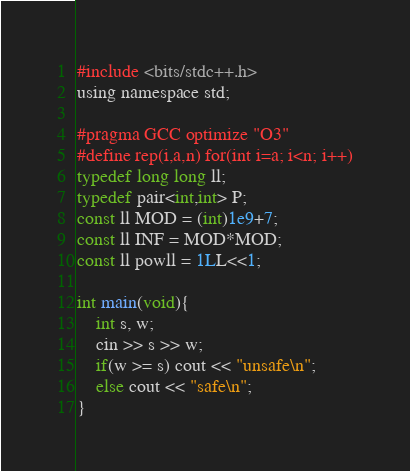<code> <loc_0><loc_0><loc_500><loc_500><_C_>#include <bits/stdc++.h>
using namespace std;

#pragma GCC optimize "O3"
#define rep(i,a,n) for(int i=a; i<n; i++)
typedef long long ll;
typedef pair<int,int> P;
const ll MOD = (int)1e9+7;
const ll INF = MOD*MOD;
const ll powll = 1LL<<1;

int main(void){
    int s, w;
    cin >> s >> w;
    if(w >= s) cout << "unsafe\n";
    else cout << "safe\n";
}</code> 